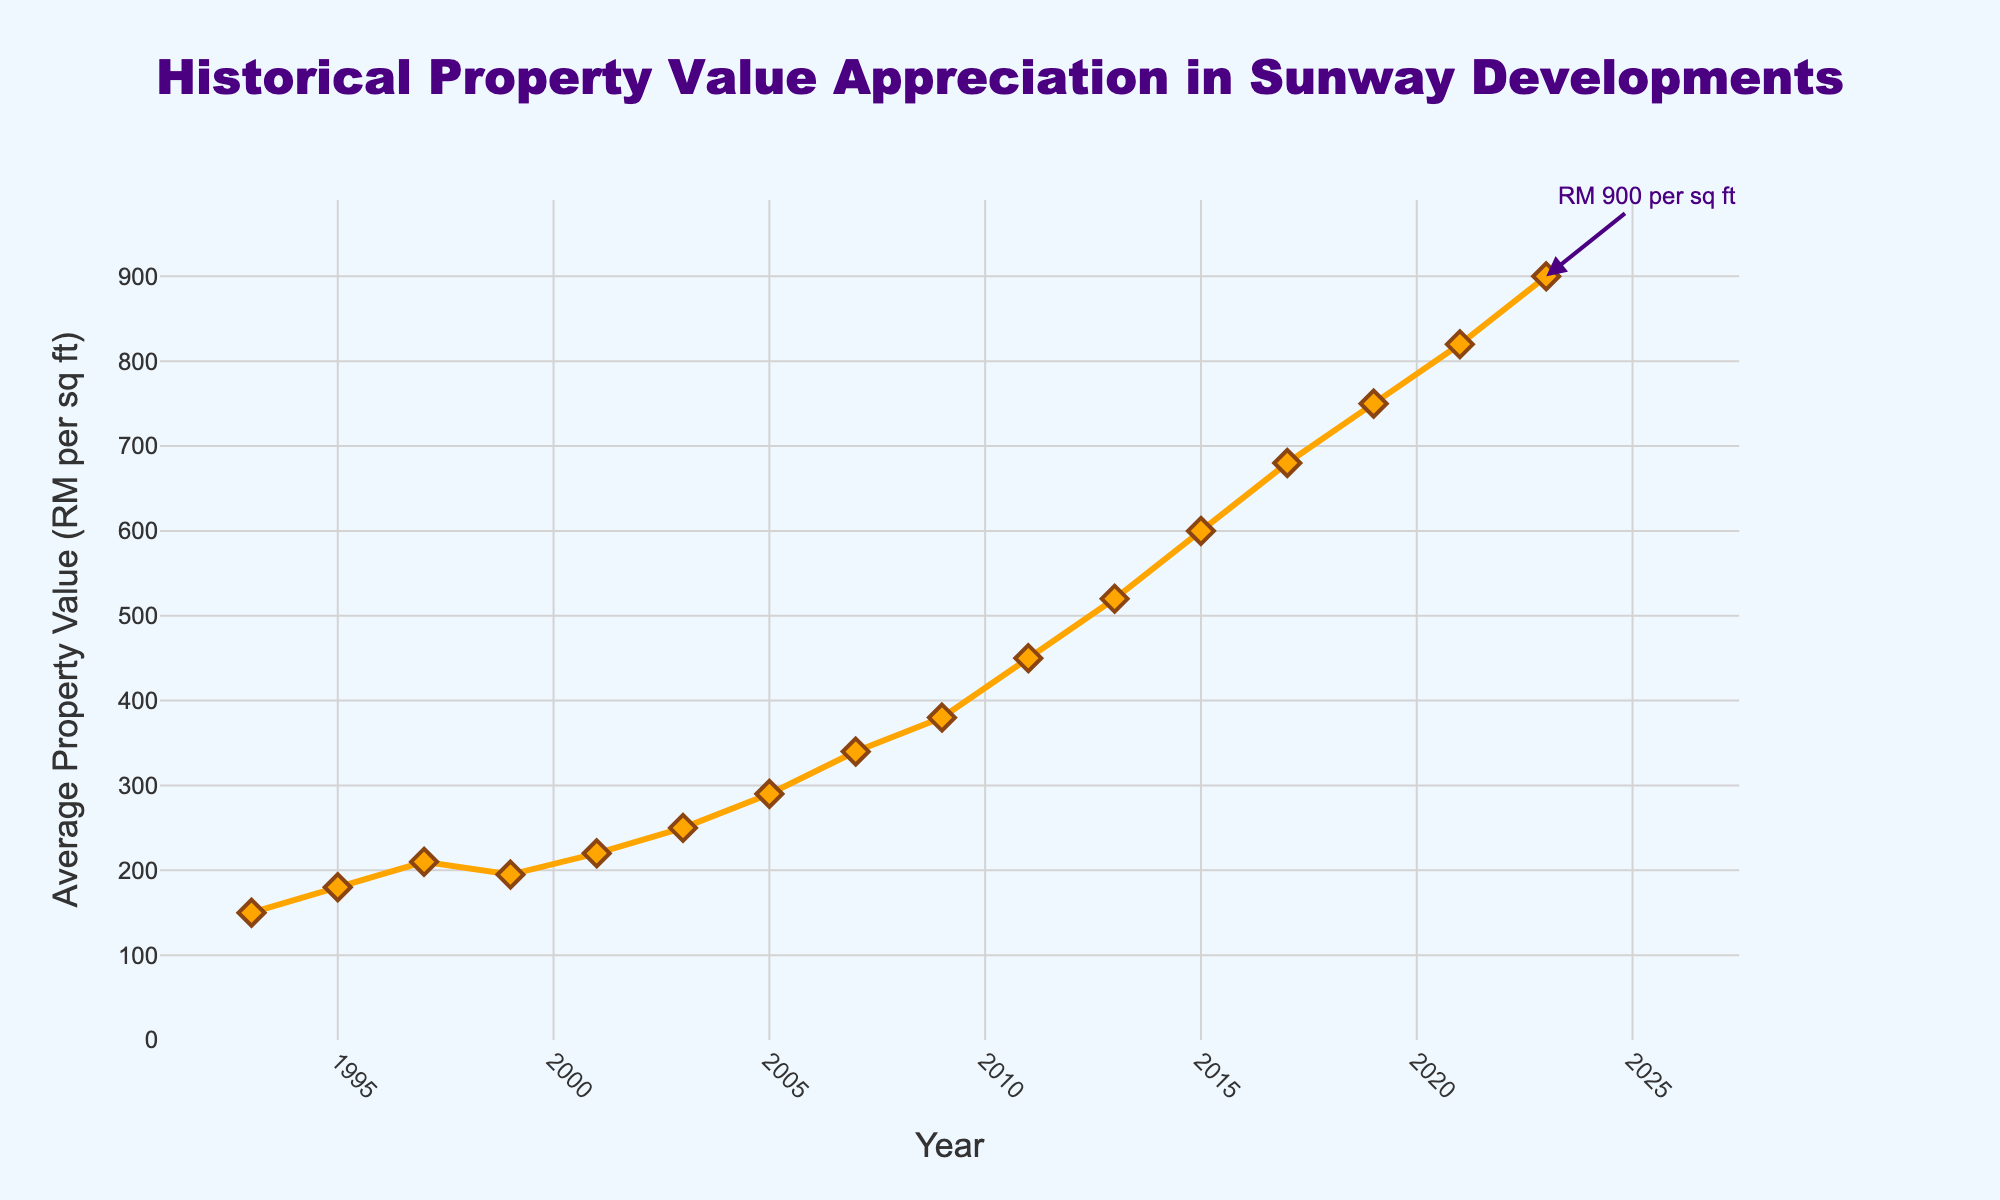Which year shows the highest average property value? The figure shows the historical property value appreciation over the years. The highest value is at the end of the plot for the year 2023.
Answer: 2023 By how much did the average property value increase between 1993 and 2023? From the figure, the average property value in 1993 is RM 150 per sq ft and in 2023 is RM 900 per sq ft. The increase is 900 - 150.
Answer: RM 750 per sq ft What is the average property value for the years 2011, 2013, and 2015? Look at the figure to find the values for the years 2011 (RM 450), 2013 (RM 520), and 2015 (RM 600). The average is calculated as (450 + 520 + 600) / 3.
Answer: RM 523.33 per sq ft Between which consecutive years did the property value experience the sharpest increase? By examining the figure's gradients, the sharpest increase is observed between 2009 and 2011, as the property value moves from RM 380 to RM 450 per sq ft.
Answer: 2009-2011 How much did the average property value appreciate between 1995 and 1997, and between 2003 and 2005? From the figure, the value in 1995 is RM 180 and in 1997 is RM 210, increasing by 30. The value in 2003 is RM 250 and in 2005 is RM 290, increasing by 40.
Answer: RM 30 per sq ft and RM 40 per sq ft Which time period had nearly stagnant property values? The figure shows a relatively stagnant value around 1997 to 1999 where it moves from RM 210 to RM 195 per sq ft.
Answer: 1997-1999 What is the percentage increase in property value from 2019 to 2023? The value in 2019 is RM 750 and in 2023 is RM 900. The percentage increase is ((900 - 750) / 750) * 100%.
Answer: 20% How does the property value trend in the first decade (1993-2003) compare to the last decade (2013-2023)? In the first decade, the property value increased from RM 150 to RM 250 (+RM 100). In the last decade, the value increased from RM 520 to RM 900 (+RM 380).
Answer: First decade +RM 100, last decade +RM 380 